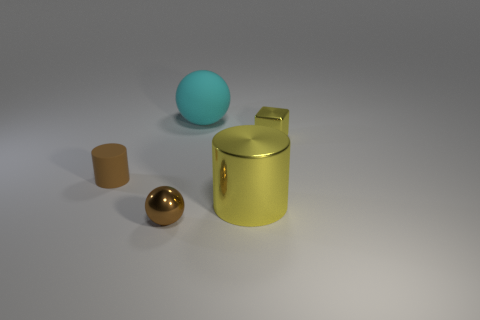Is there any other thing that has the same shape as the brown matte object?
Make the answer very short. Yes. What number of things are either spheres that are in front of the shiny block or cyan cylinders?
Offer a very short reply. 1. There is a small shiny object that is behind the small cylinder; does it have the same color as the tiny cylinder?
Give a very brief answer. No. The yellow thing in front of the tiny thing that is right of the cyan rubber thing is what shape?
Your response must be concise. Cylinder. Is the number of large cyan matte things in front of the yellow metal cube less than the number of small spheres that are right of the big cyan object?
Provide a succinct answer. No. There is a brown thing that is the same shape as the cyan matte object; what size is it?
Offer a terse response. Small. Is there anything else that has the same size as the yellow shiny block?
Give a very brief answer. Yes. How many things are either brown objects behind the tiny ball or metallic objects that are right of the cyan object?
Ensure brevity in your answer.  3. Is the size of the brown cylinder the same as the cyan matte thing?
Provide a succinct answer. No. Are there more small cyan matte blocks than small brown cylinders?
Make the answer very short. No. 